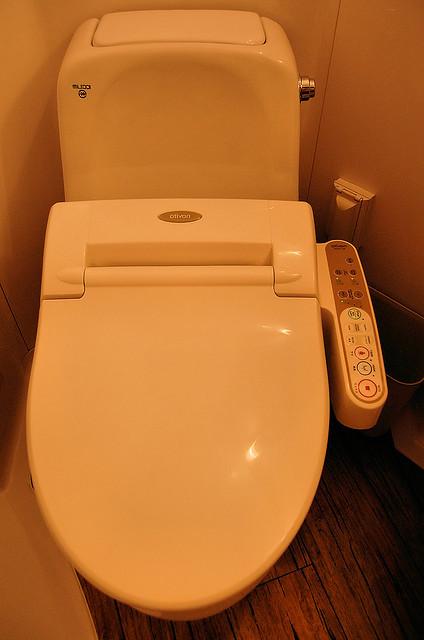Does this toilet have flush handle or button?
Keep it brief. Button. Who is using the toilet?
Give a very brief answer. Nobody. Does that toilet probably have a bidet function?
Quick response, please. Yes. 